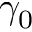Convert formula to latex. <formula><loc_0><loc_0><loc_500><loc_500>\gamma _ { 0 }</formula> 